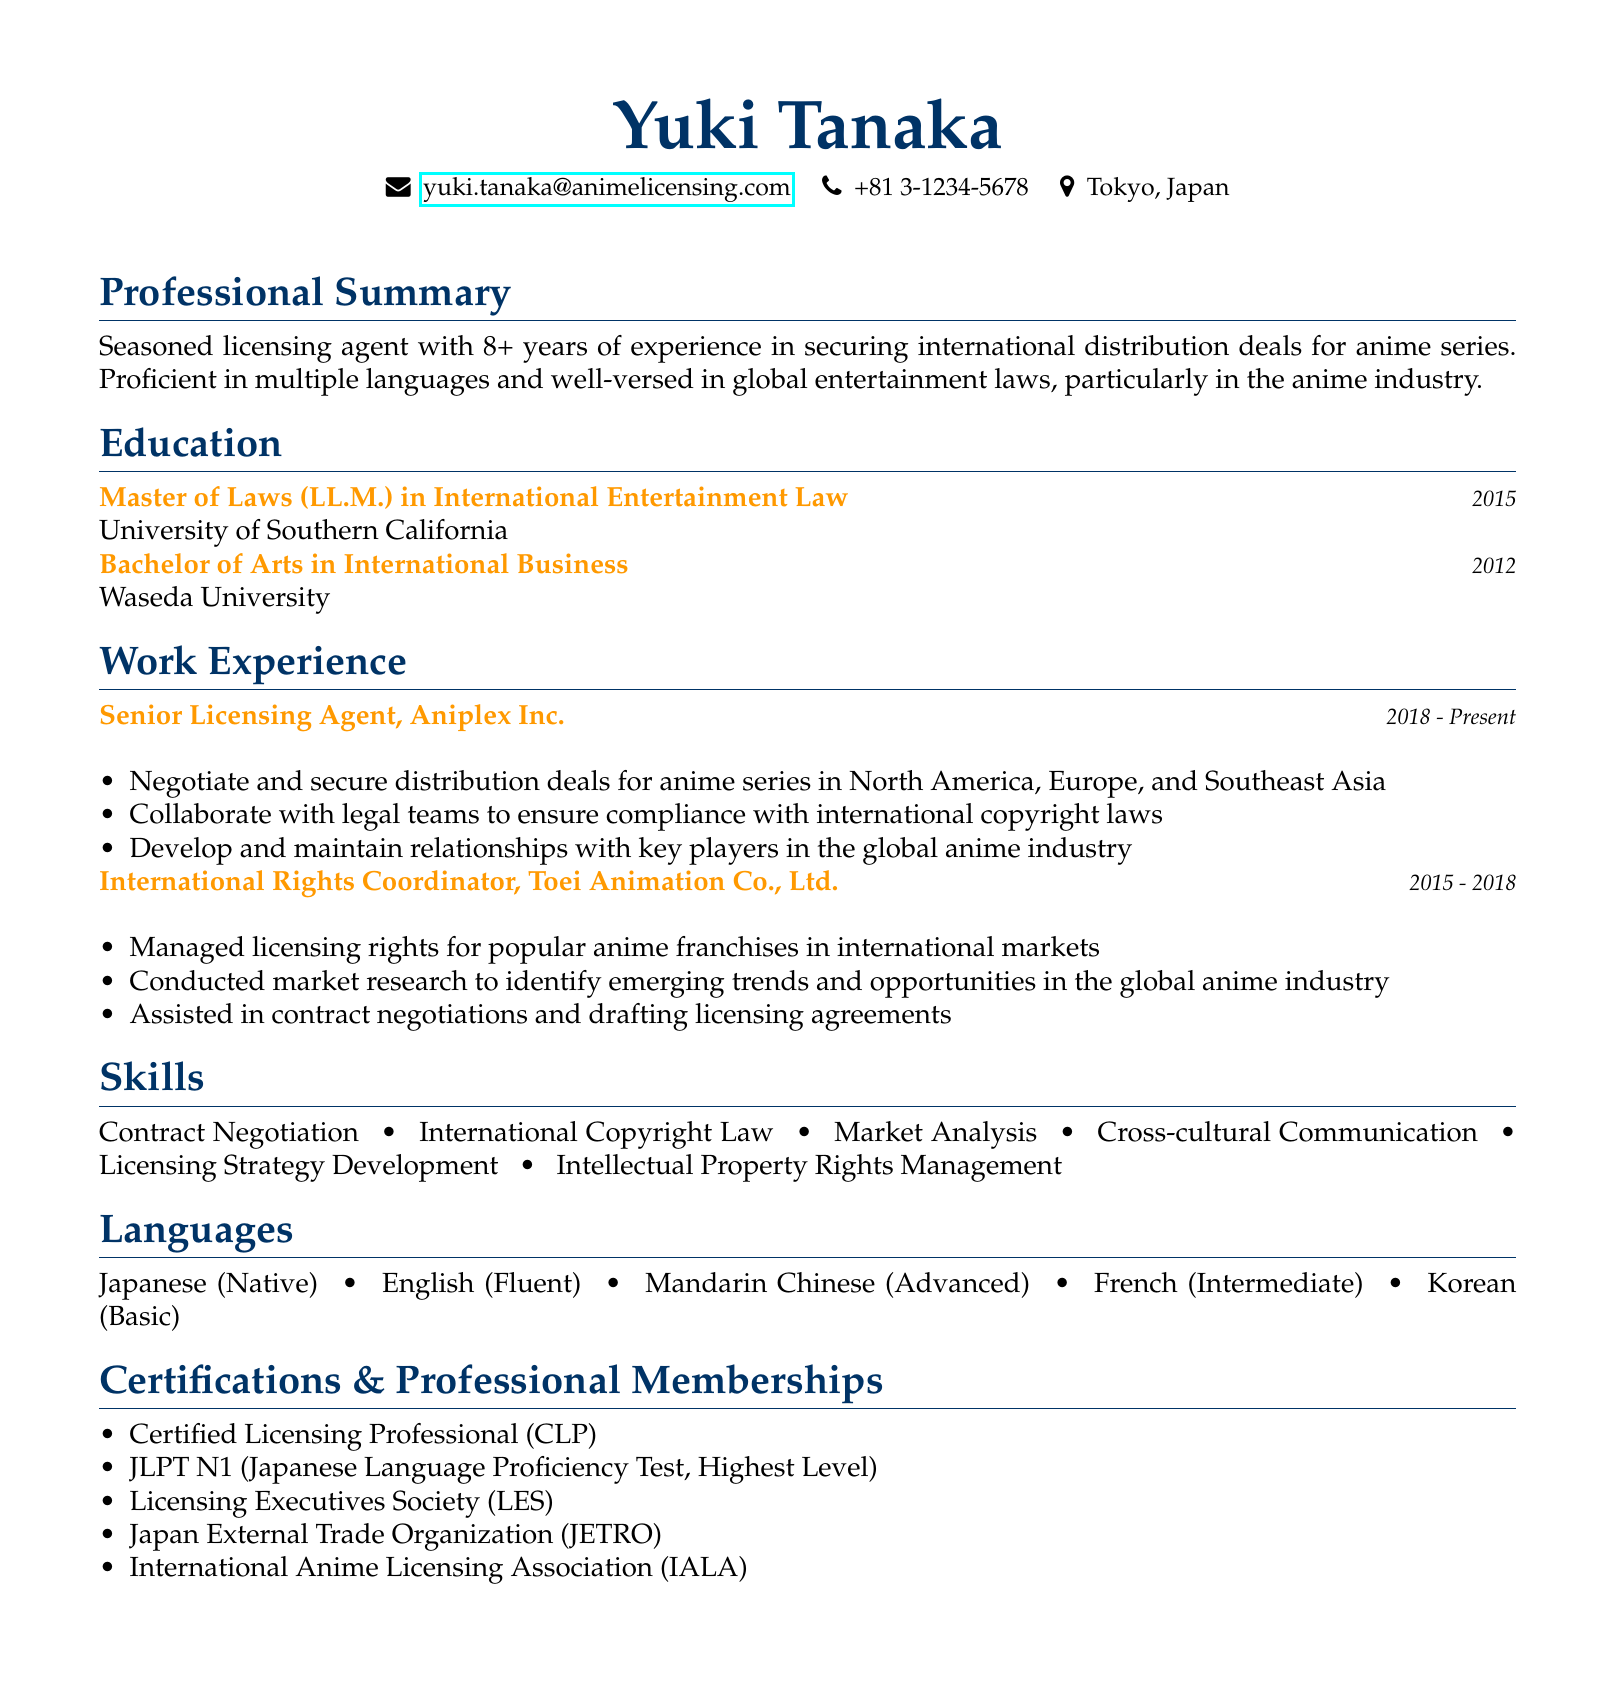What is the name of the candidate? The name of the candidate is prominently displayed at the top of the document.
Answer: Yuki Tanaka How many years of experience does Yuki Tanaka have? The professional summary explicitly mentions the number of years of experience in the anime licensing industry.
Answer: 8+ What is the highest degree held by Yuki Tanaka? The education section lists degrees held, and the highest one is indicated.
Answer: Master of Laws (LL.M.) In which company does Yuki Tanaka currently work? The work experience section states the current position and company clearly.
Answer: Aniplex Inc What language proficiency is indicated at the highest level? The languages section includes language levels, highlighting the proficiency in Japanese.
Answer: Native What is one of Yuki Tanaka's skills listed in the CV? The skills section enumerates several important skills relevant to the industry.
Answer: Contract Negotiation What certification does Yuki Tanaka hold that relates to licensing? The certifications section includes relevant professional credentials.
Answer: Certified Licensing Professional (CLP) What year did Yuki Tanaka graduate from Waseda University? The education section specifies the year of graduation for the Bachelor's degree.
Answer: 2012 